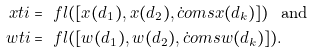<formula> <loc_0><loc_0><loc_500><loc_500>\ x t i & = \ f l ( [ x ( d _ { 1 } ) , x ( d _ { 2 } ) , \dot { c } o m s x ( d _ { k } ) ] ) \ \text { and } \\ \ w t i & = \ f l ( [ w ( d _ { 1 } ) , w ( d _ { 2 } ) , \dot { c } o m s w ( d _ { k } ) ] ) .</formula> 